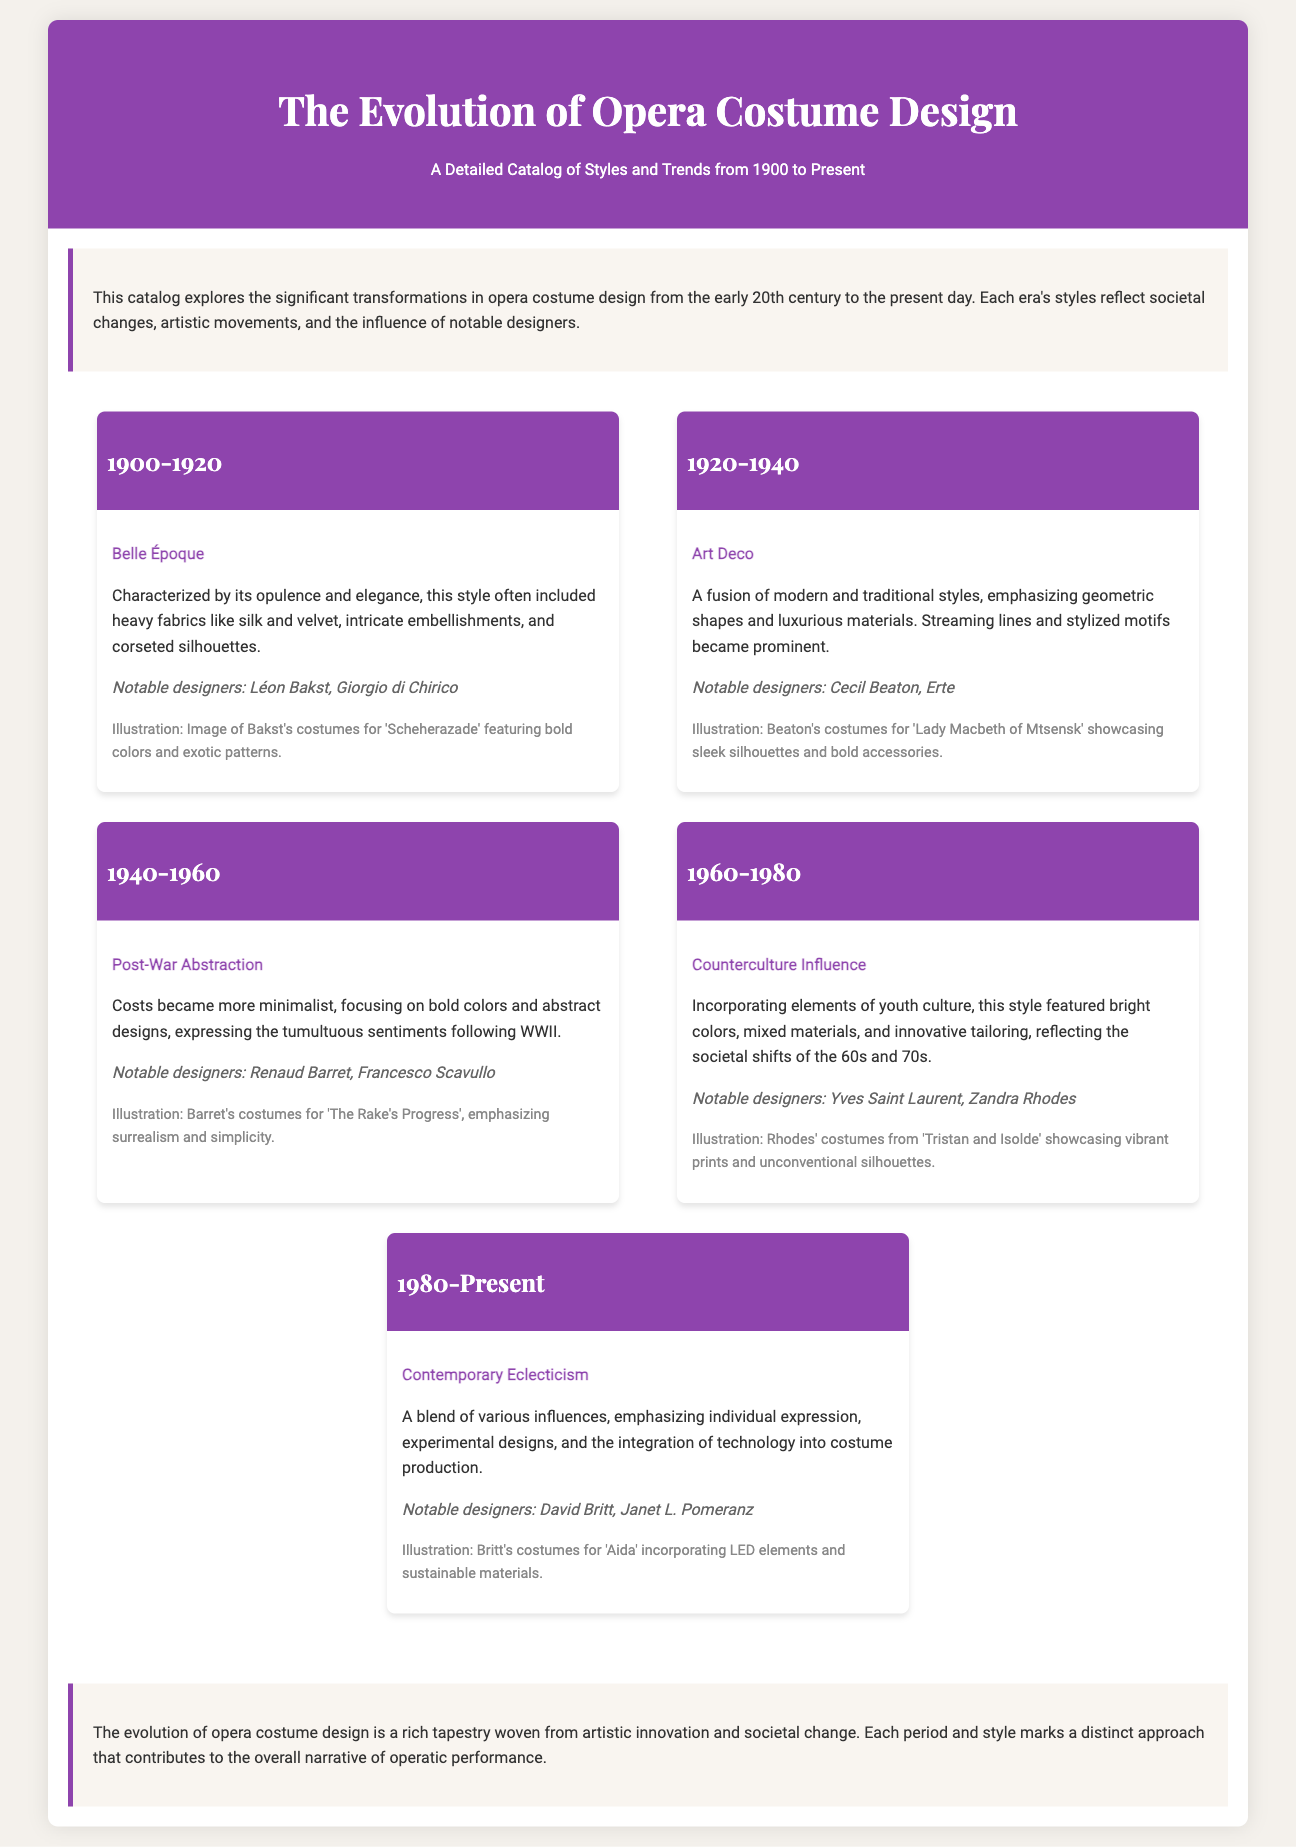What is the title of the catalog? The title of the catalog is provided in the header section, which indicates it focuses on the evolution of opera costume design.
Answer: The Evolution of Opera Costume Design What is the time period covered in the first era? The first era highlighted in the document covers the years from 1900 to 1920.
Answer: 1900-1920 What style is associated with the years 1920 to 1940? The era from 1920 to 1940 is defined by a specific style noted in the document.
Answer: Art Deco Who designed costumes for 'Lady Macbeth of Mtsensk'? The document lists notable designers for various productions, including 'Lady Macbeth of Mtsensk'.
Answer: Cecil Beaton What is a characteristic of the contemporary era's costume design? The document describes this era by noting a significant feature of the costume design style from 1980 to the present.
Answer: Individual expression Which era is characterized by the influence of youth culture? The document specifies an era that incorporates youth culture in its styles and designs.
Answer: 1960-1980 What notable materials are mentioned in the costumes for 'Aida'? The document describes specific innovative features in the costumes for 'Aida'.
Answer: LED elements and sustainable materials Who is a notable designer from the 1940-1960 era? The catalog highlights designers for each era, including the one for 1940-1960.
Answer: Renaud Barret 